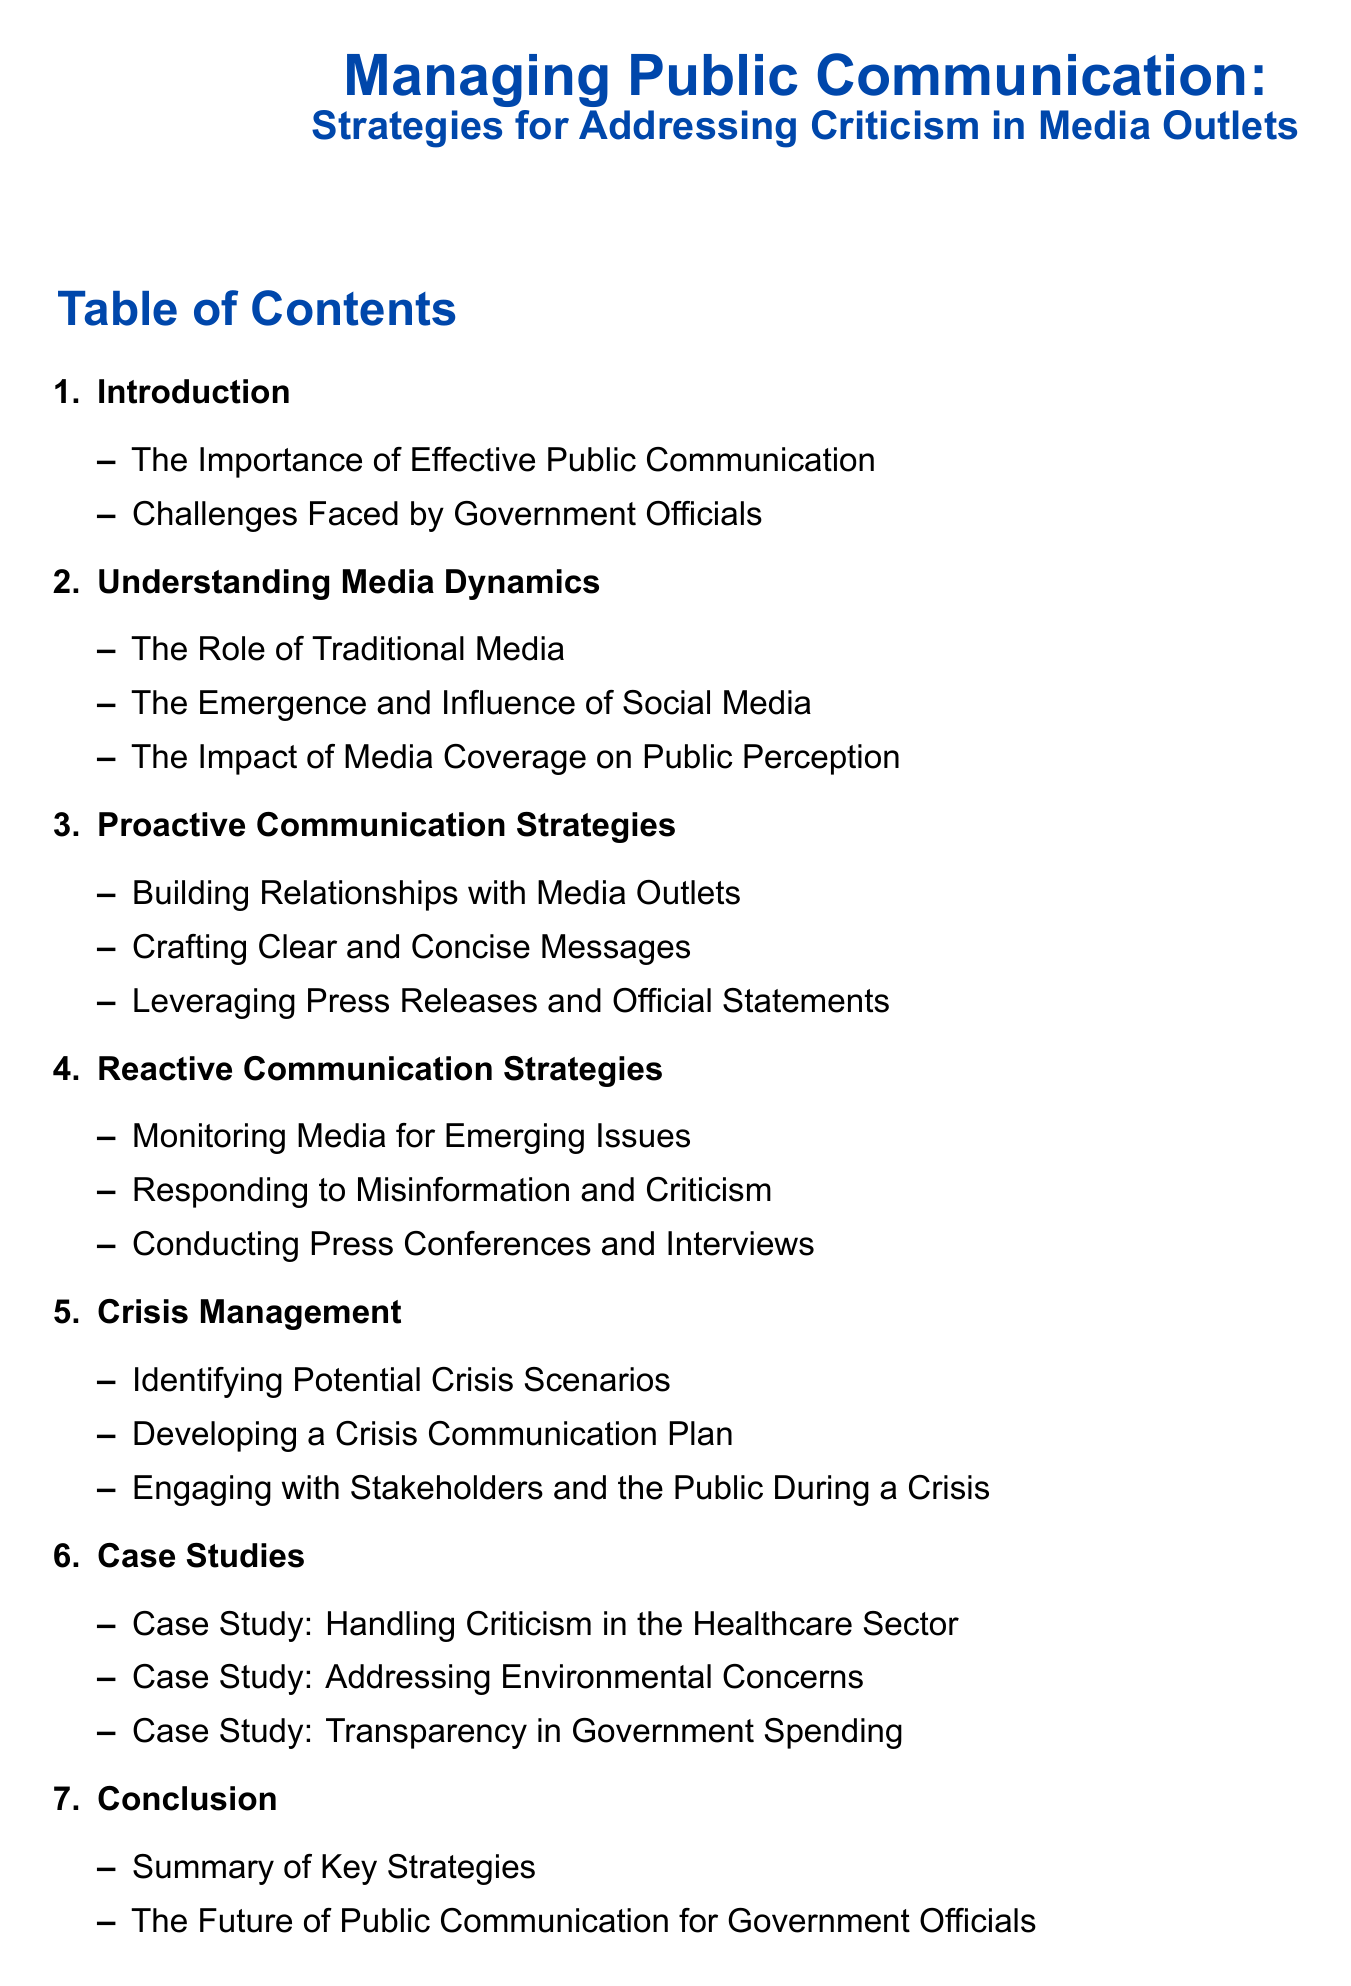what is the title of the document? The title of the document is the main heading presented at the top after the introduction, which summarizes the topic of the document.
Answer: Managing Public Communication: Strategies for Addressing Criticism in Media Outlets how many sections are listed in the table of contents? The sections are numbered from 1 to 7, indicating the total number of sections provided in the table of contents.
Answer: 7 what is the focus of section 3? Section 3 is dedicated to specific strategies that can be employed to communicate effectively before any potential issues arise.
Answer: Proactive Communication Strategies which case study addresses criticisms related to environmental issues? The case studies outline specific examples of addressing criticism in various sectors, and one is explicitly focused on environmental issues.
Answer: Case Study: Addressing Environmental Concerns what is one aspect covered under crisis management? The crisis management section is centered around preparing for and responding to potential crises, and it consists of various important aspects.
Answer: Developing a Crisis Communication Plan what is discussed in the conclusion section? The conclusion section wraps up the key points covered in the document and discusses future implications for effective communication in public office.
Answer: Summary of Key Strategies which media is highlighted as having a traditional role in public communication? The dynamics of media are explored in terms of their roles, with some being categorized as traditional media that have long served this purpose.
Answer: Traditional Media 